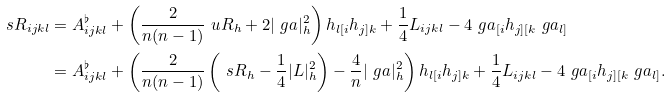Convert formula to latex. <formula><loc_0><loc_0><loc_500><loc_500>\ s R _ { i j k l } & = A ^ { \flat } _ { i j k l } + \left ( \frac { 2 } { n ( n - 1 ) } \ u R _ { h } + 2 | \ g a | _ { h } ^ { 2 } \right ) h _ { l [ i } h _ { j ] k } + \frac { 1 } { 4 } L _ { i j k l } - 4 \ g a _ { [ i } h _ { j ] [ k } \ g a _ { l ] } \\ & = A ^ { \flat } _ { i j k l } + \left ( \frac { 2 } { n ( n - 1 ) } \left ( \ s R _ { h } - \frac { 1 } { 4 } | L | _ { h } ^ { 2 } \right ) - \frac { 4 } { n } | \ g a | _ { h } ^ { 2 } \right ) h _ { l [ i } h _ { j ] k } + \frac { 1 } { 4 } L _ { i j k l } - 4 \ g a _ { [ i } h _ { j ] [ k } \ g a _ { l ] } .</formula> 